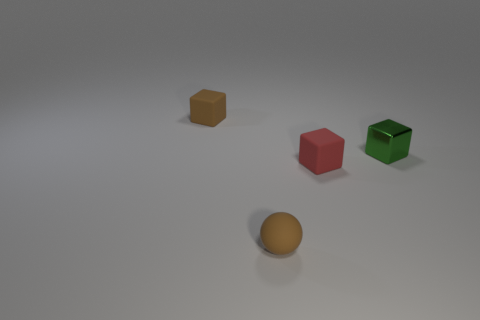Add 2 green rubber balls. How many objects exist? 6 Subtract all balls. How many objects are left? 3 Subtract all tiny cubes. Subtract all small brown blocks. How many objects are left? 0 Add 1 balls. How many balls are left? 2 Add 1 big red shiny cylinders. How many big red shiny cylinders exist? 1 Subtract 0 gray balls. How many objects are left? 4 